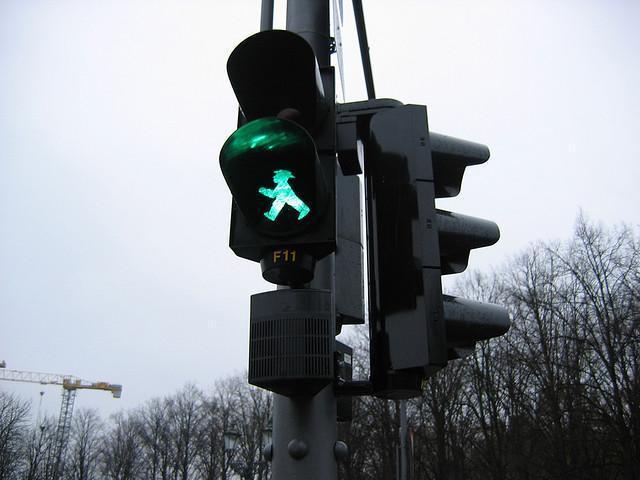How many traffic lights are there?
Give a very brief answer. 2. How many white cars are on the road?
Give a very brief answer. 0. 